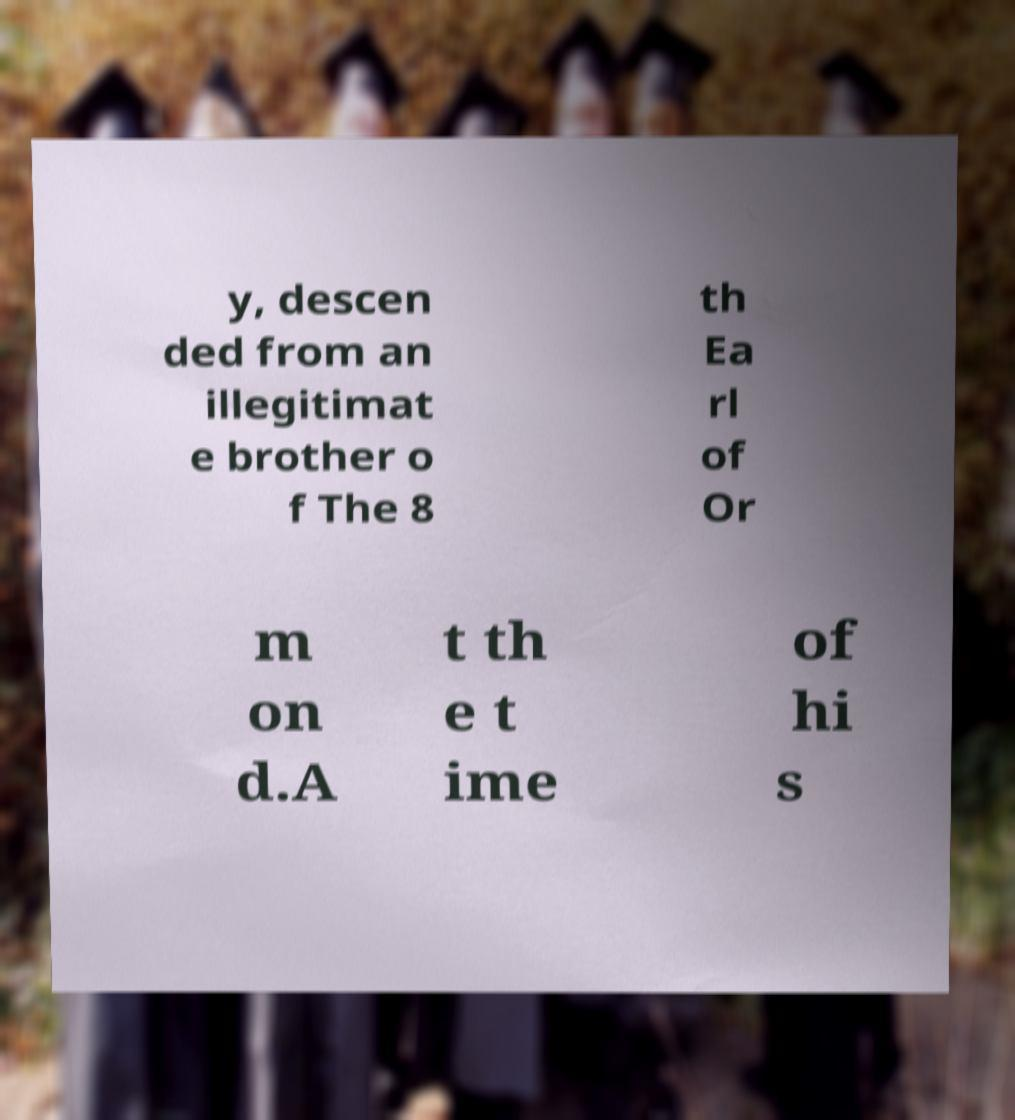Please identify and transcribe the text found in this image. y, descen ded from an illegitimat e brother o f The 8 th Ea rl of Or m on d.A t th e t ime of hi s 